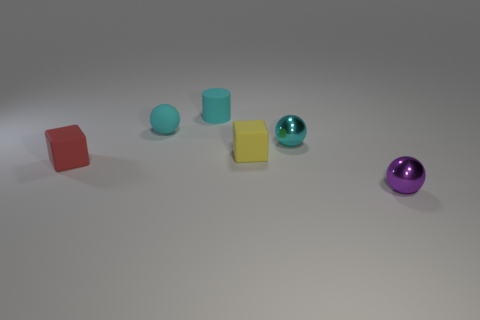Add 2 small cyan cylinders. How many objects exist? 8 Subtract all cubes. How many objects are left? 4 Add 5 purple metallic balls. How many purple metallic balls are left? 6 Add 3 purple metal objects. How many purple metal objects exist? 4 Subtract 0 gray blocks. How many objects are left? 6 Subtract all rubber spheres. Subtract all small red rubber objects. How many objects are left? 4 